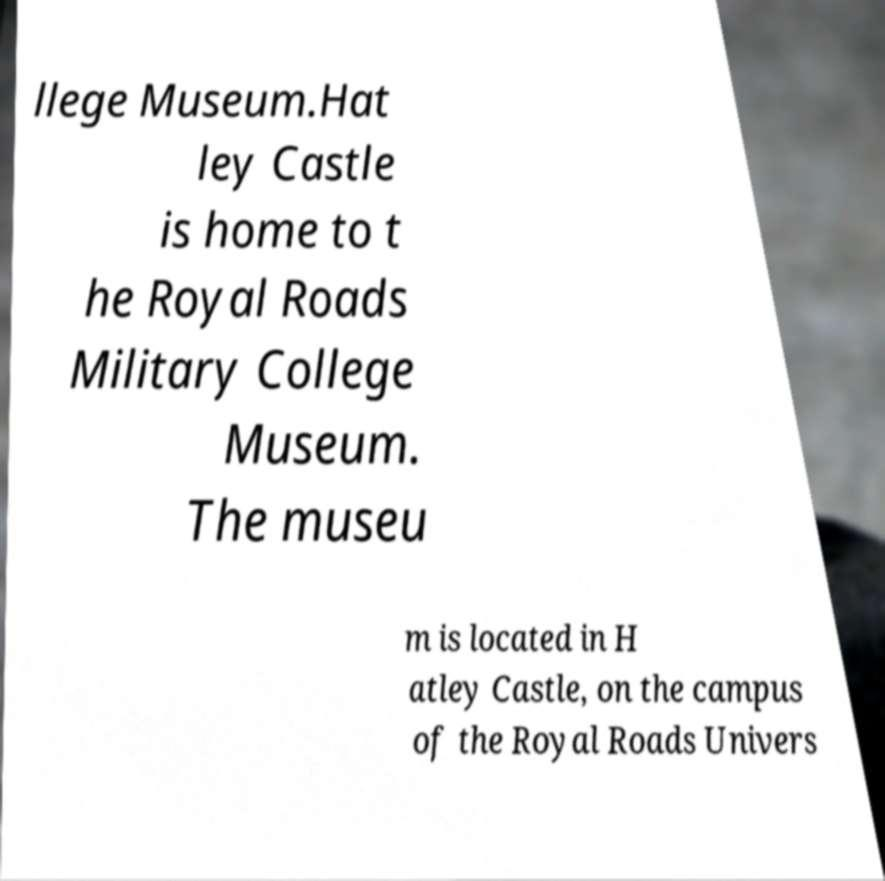Can you read and provide the text displayed in the image?This photo seems to have some interesting text. Can you extract and type it out for me? llege Museum.Hat ley Castle is home to t he Royal Roads Military College Museum. The museu m is located in H atley Castle, on the campus of the Royal Roads Univers 